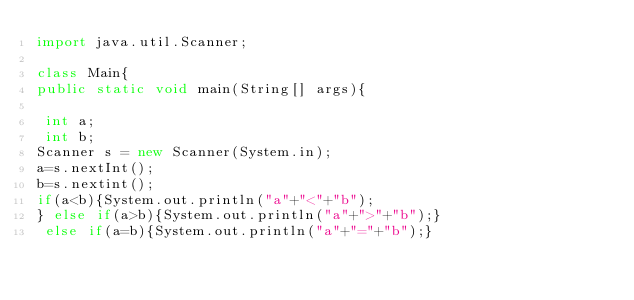<code> <loc_0><loc_0><loc_500><loc_500><_Java_>import java.util.Scanner;

class Main{
public static void main(String[] args){

 int a;
 int b;
Scanner s = new Scanner(System.in);
a=s.nextInt();
b=s.nextint();
if(a<b){System.out.println("a"+"<"+"b");
} else if(a>b){System.out.println("a"+">"+"b");}
 else if(a=b){System.out.println("a"+"="+"b");}
</code> 